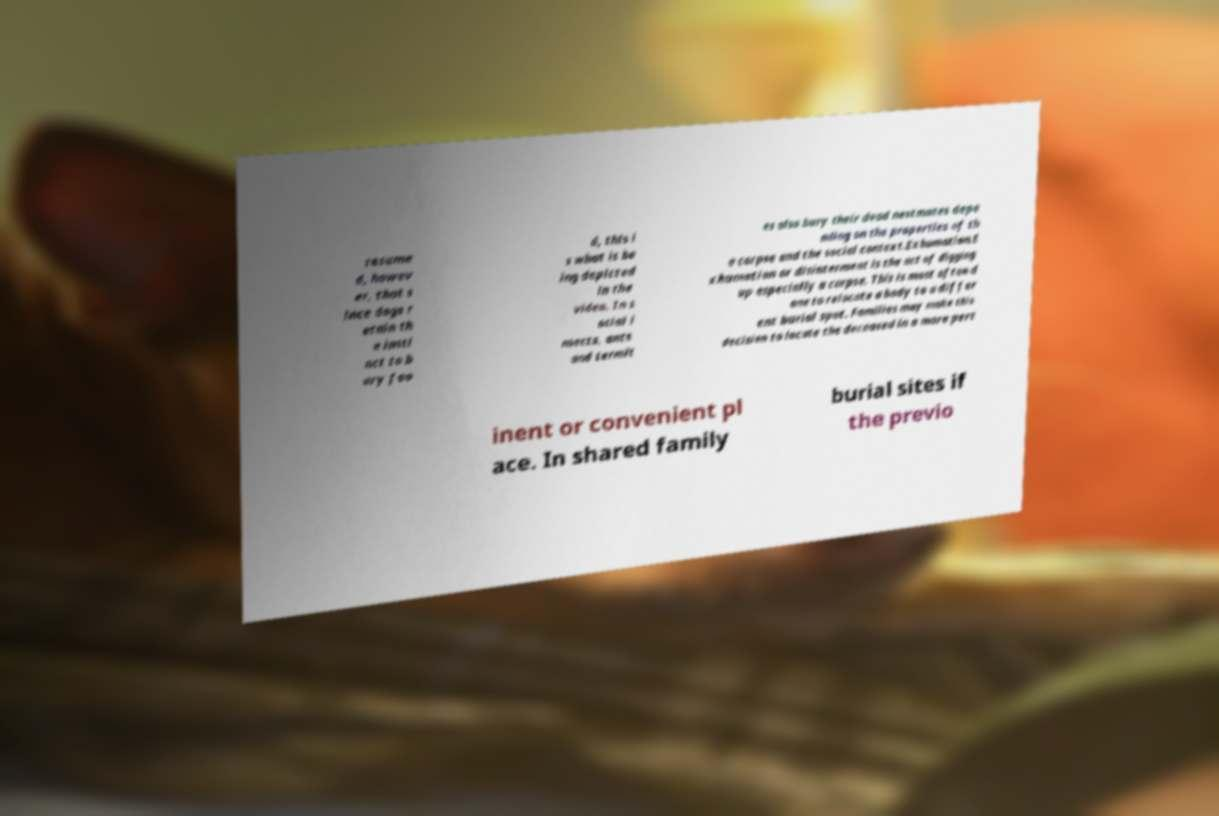Please read and relay the text visible in this image. What does it say? resume d, howev er, that s ince dogs r etain th e insti nct to b ury foo d, this i s what is be ing depicted in the video. In s ocial i nsects, ants and termit es also bury their dead nestmates depe nding on the properties of th e corpse and the social context.Exhumation.E xhumation or disinterment is the act of digging up especially a corpse. This is most often d one to relocate a body to a differ ent burial spot. Families may make this decision to locate the deceased in a more pert inent or convenient pl ace. In shared family burial sites if the previo 